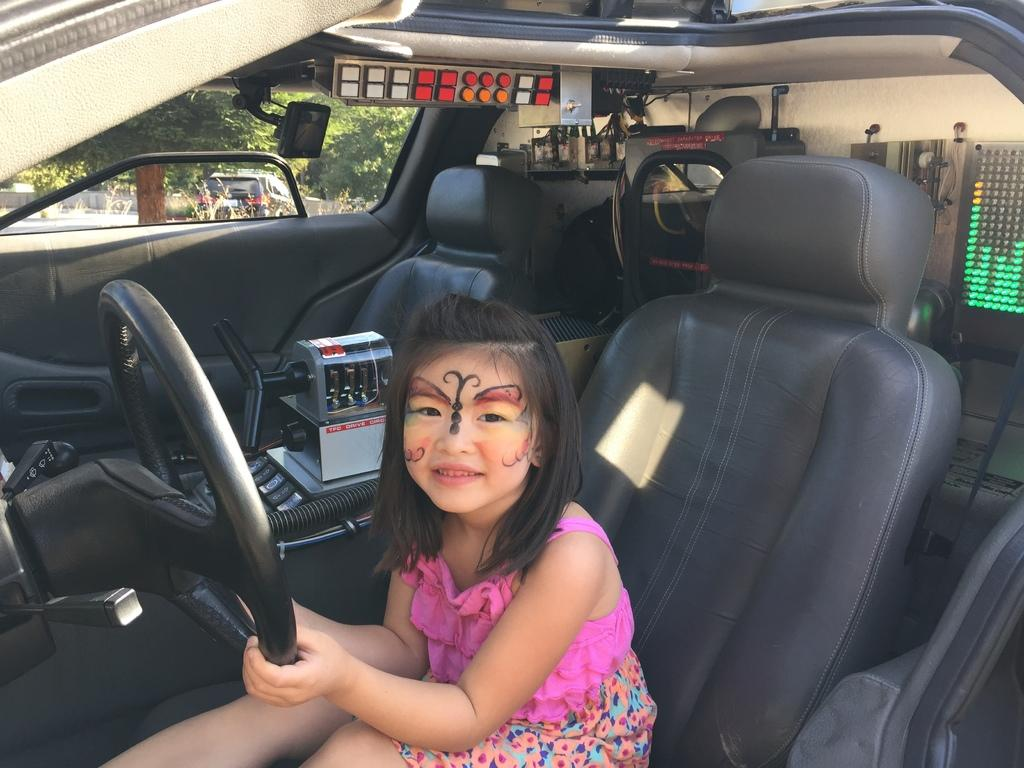What is the girl doing inside the car? The girl is sitting inside the car and holding a steering wheel. What can be seen from the car window? Trees and vehicles are visible from the car window. Is the girl standing on an island in the image? No, the girl is sitting inside a car in the image, and there is no indication of an island. 